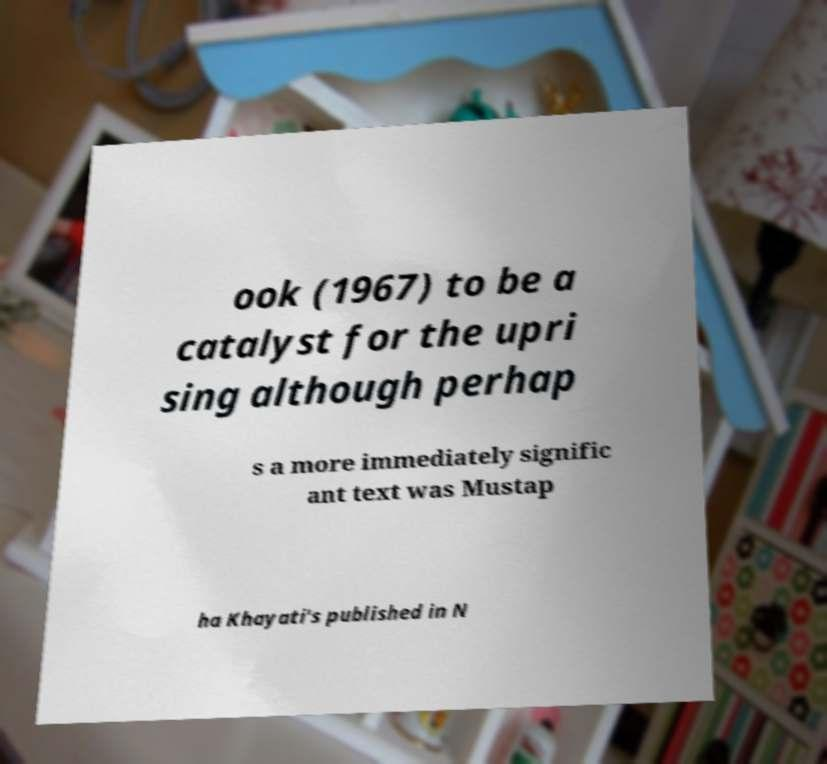Please read and relay the text visible in this image. What does it say? ook (1967) to be a catalyst for the upri sing although perhap s a more immediately signific ant text was Mustap ha Khayati's published in N 